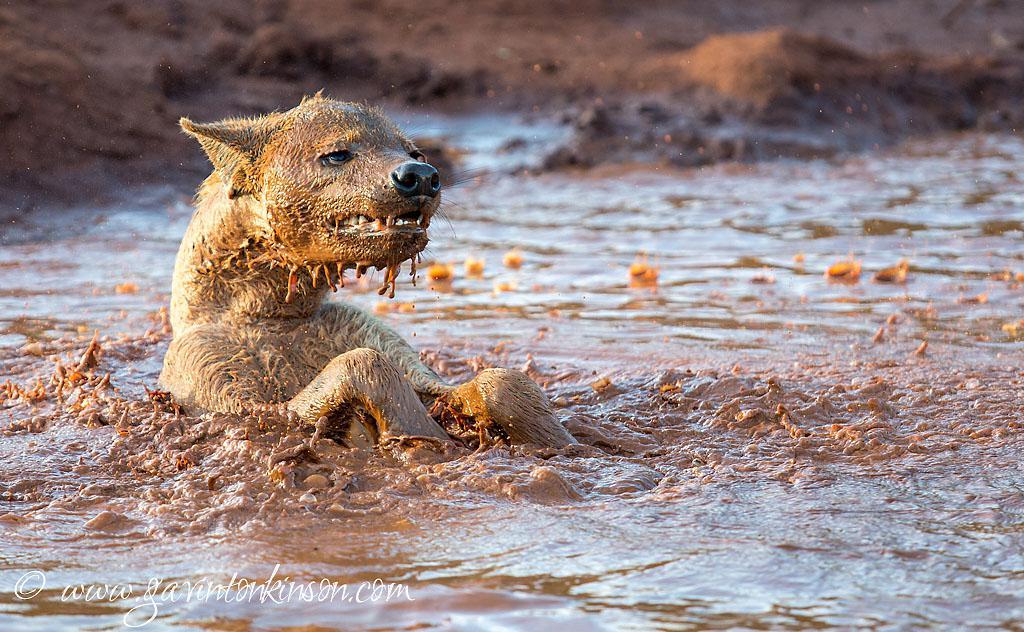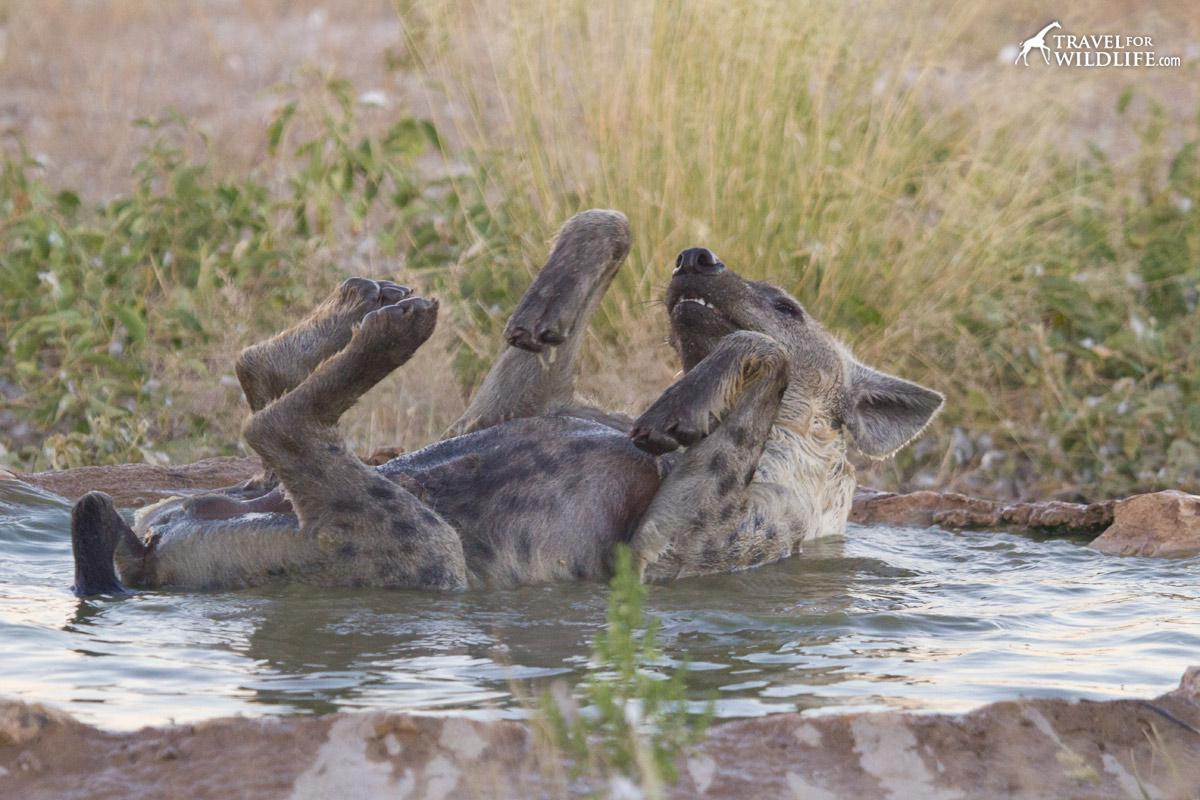The first image is the image on the left, the second image is the image on the right. Analyze the images presented: Is the assertion "The right image shows one hyena on its back in water, with its head and at least its front paws sticking up in the air." valid? Answer yes or no. Yes. The first image is the image on the left, the second image is the image on the right. For the images displayed, is the sentence "The left and right image contains the same number of hyenas in the water." factually correct? Answer yes or no. Yes. 